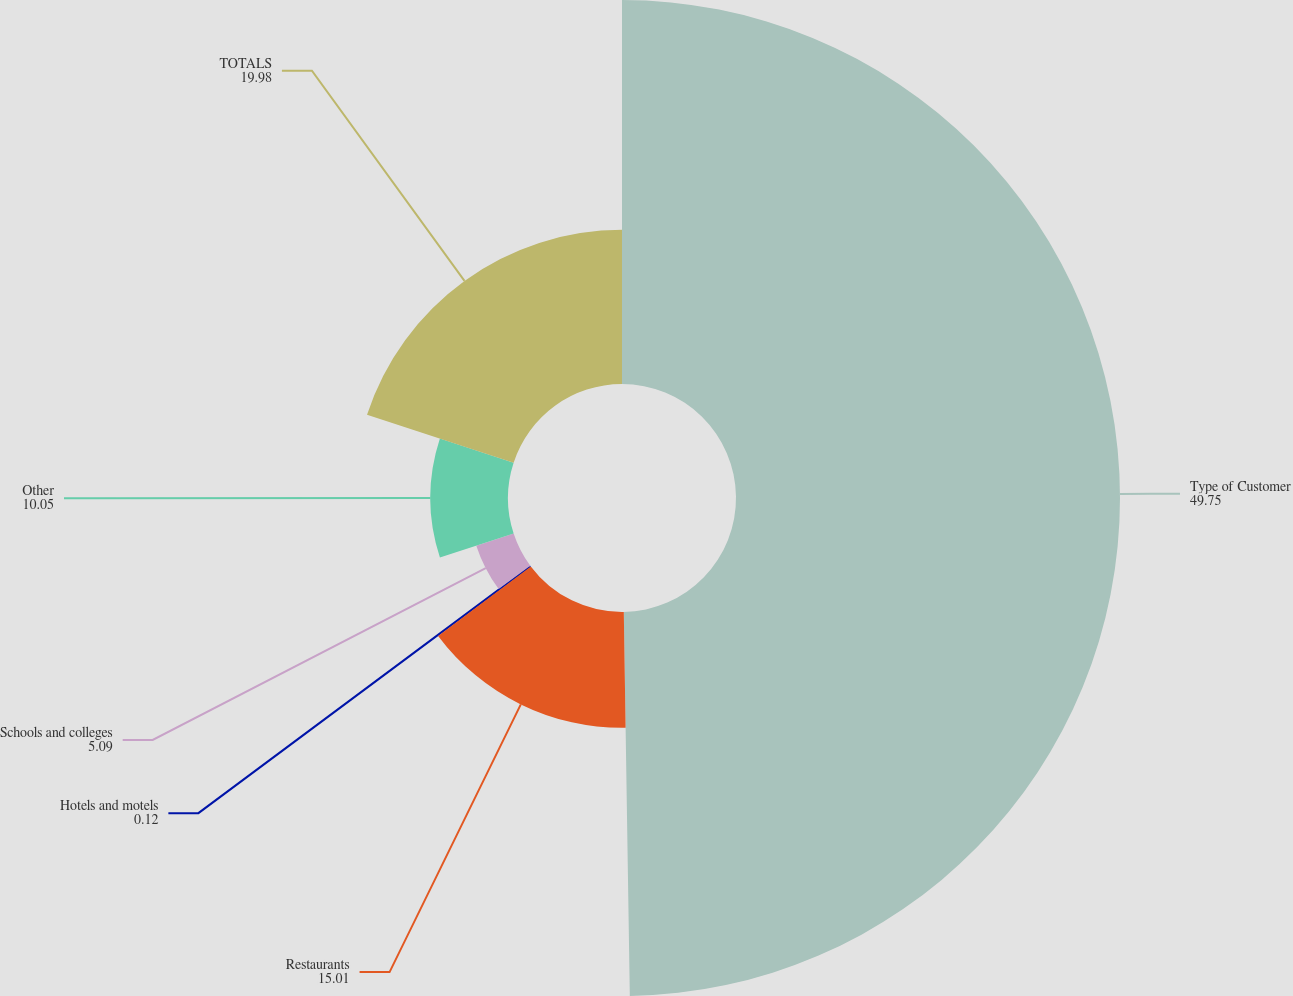Convert chart to OTSL. <chart><loc_0><loc_0><loc_500><loc_500><pie_chart><fcel>Type of Customer<fcel>Restaurants<fcel>Hotels and motels<fcel>Schools and colleges<fcel>Other<fcel>TOTALS<nl><fcel>49.75%<fcel>15.01%<fcel>0.12%<fcel>5.09%<fcel>10.05%<fcel>19.98%<nl></chart> 